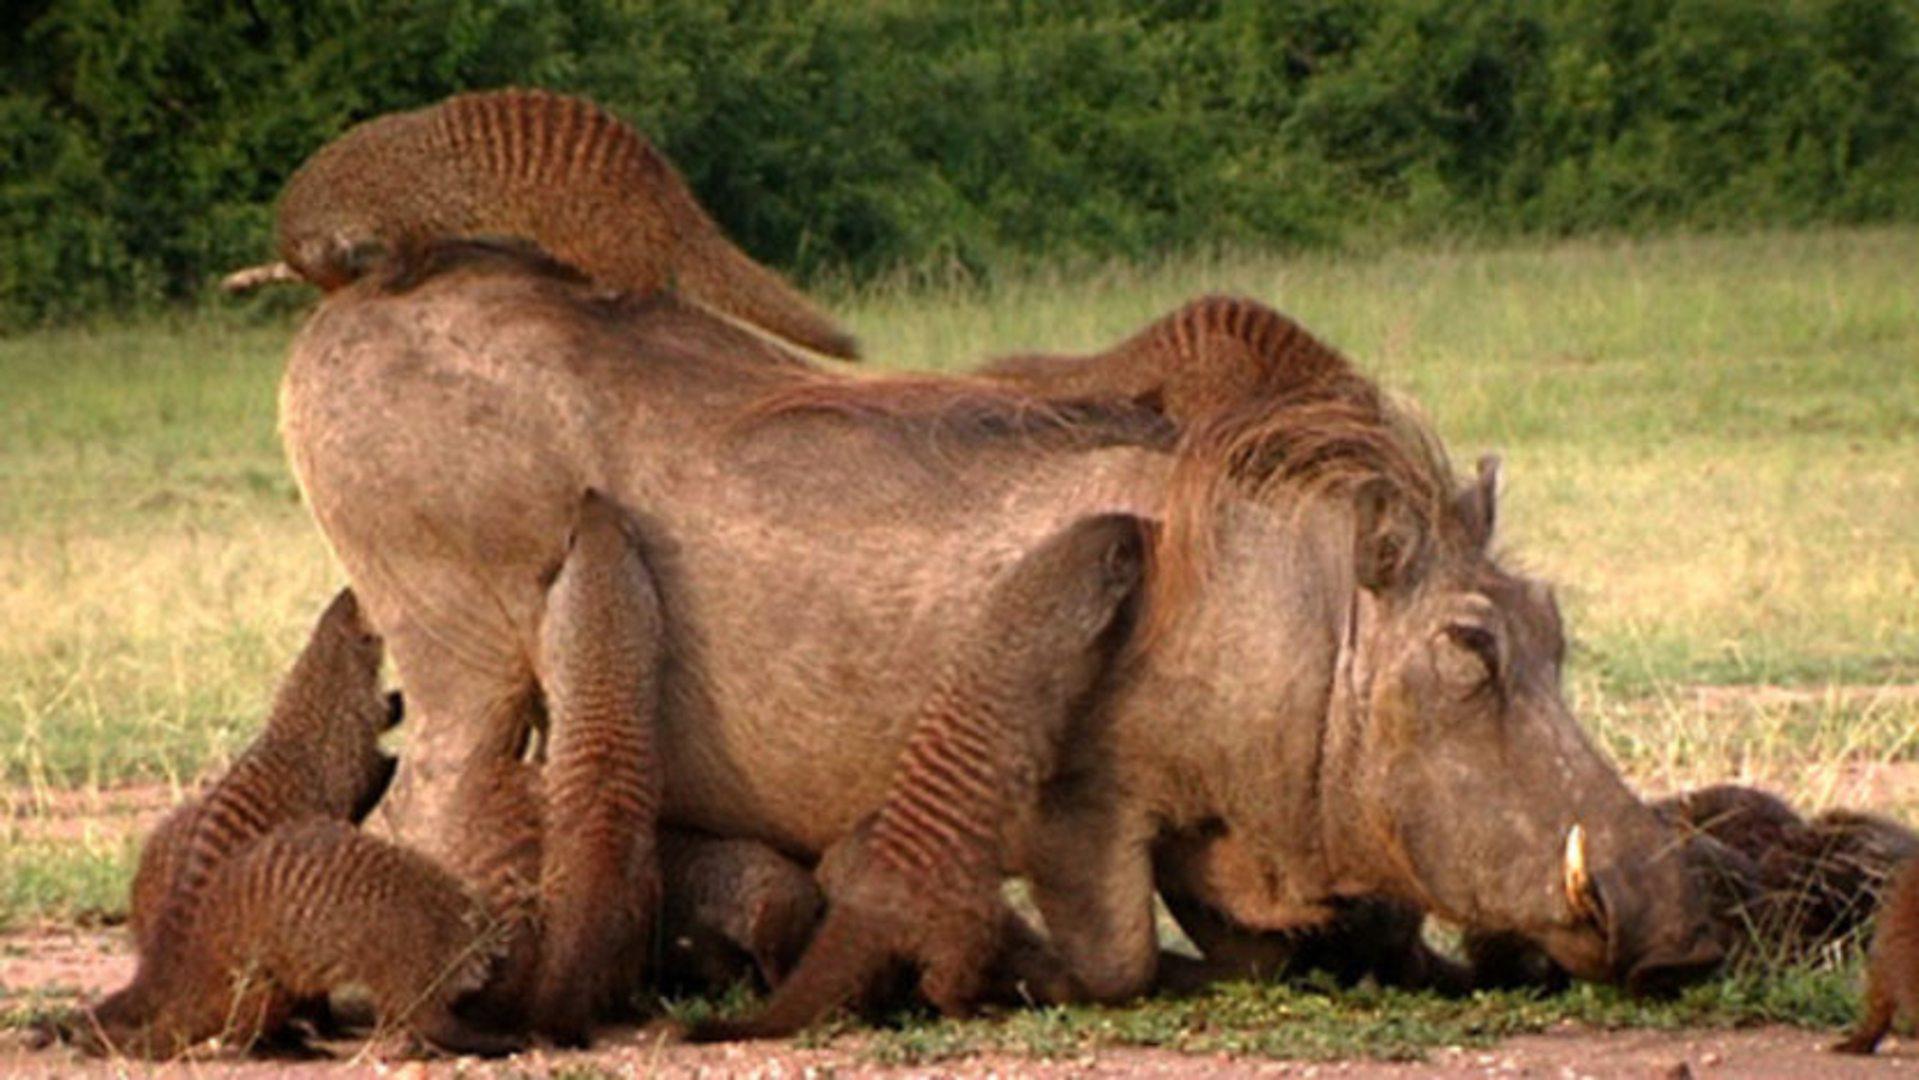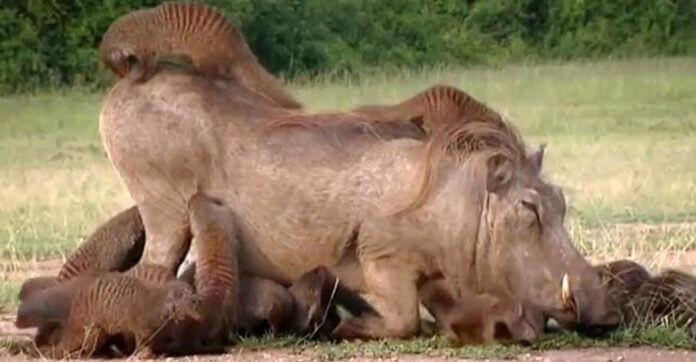The first image is the image on the left, the second image is the image on the right. Examine the images to the left and right. Is the description "Each image shows multiple small striped mammals crawling on and around one warthog, and the warthogs in the two images are in the same type of pose." accurate? Answer yes or no. Yes. 